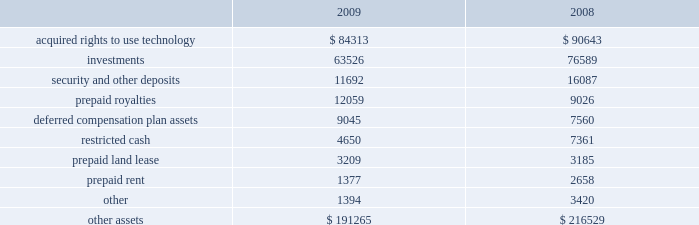Adobe systems incorporated notes to consolidated financial statements ( continued ) note 8 .
Other assets other assets as of november 27 , 2009 and november 28 , 2008 consisted of the following ( in thousands ) : .
Acquired rights to use technology purchased during fiscal 2009 and fiscal 2008 was $ 6.0 million and $ 100.4 million , respectively .
Of the cost for fiscal 2008 , an estimated $ 56.4 million was related to future licensing rights and has been capitalized and is being amortized on a straight-line basis over the estimated useful lives up to fifteen years .
Of the remaining costs for fiscal 2008 , we estimated that $ 27.2 million was related to historical use of licensing rights which was expensed as cost of sales and the residual of $ 16.8 million for fiscal 2008 was expensed as general and administrative costs .
In connection with these licensing arrangements , we have the ability to acquire additional rights to use technology in the future .
See note 17 for further information regarding our contractual commitments .
In general , acquired rights to use technology are amortized over their estimated useful lives of 3 to 15 years .
Included in investments are our indirect investments through our limited partnership interest in adobe ventures of approximately $ 37.1 million and $ 39.0 million as of november 27 , 2009 and november 28 , 2008 , respectively , which is consolidated in accordance with the provisions for consolidating variable interest entities .
The partnership is controlled by granite ventures , an independent venture capital firm and sole general partner of adobe ventures .
We are the primary beneficiary of adobe ventures and bear virtually all of the risks and rewards related to our ownership .
Our investment in adobe ventures does not have a significant impact on our consolidated financial position , results of operations or cash flows .
Adobe ventures carries its investments in equity securities at estimated fair value and investment gains and losses are included in our consolidated statements of income .
Substantially all of the investments held by adobe ventures at november 27 , 2009 and november 28 , 2008 are not publicly traded and , therefore , there is no established market for these securities .
In order to determine the fair value of these investments , we use the most recent round of financing involving new non-strategic investors or estimates of current market value made by granite ventures .
It is our policy to evaluate the fair value of these investments held by adobe ventures , as well as our direct investments , on a regular basis .
This evaluation includes , but is not limited to , reviewing each company 2019s cash position , financing needs , earnings and revenue outlook , operational performance , management and ownership changes and competition .
In the case of privately-held companies , this evaluation is based on information that we request from these companies .
This information is not subject to the same disclosure regulations as u.s .
Publicly traded companies and as such , the basis for these evaluations is subject to the timing and the accuracy of the data received from these companies .
See note 4 for further information regarding adobe ventures .
Also included in investments are our direct investments in privately-held companies of approximately $ 26.4 million and $ 37.6 million as of november 27 , 2009 and november 28 , 2008 , respectively , which are accounted for based on the cost method .
We assess these investments for impairment in value as circumstances dictate .
See note 4 for further information regarding our cost method investments .
We entered into a purchase and sale agreement , effective may 12 , 2008 , for the acquisition of real property located in waltham , massachusetts .
We purchased the property upon completion of construction of an office building shell and core , parking structure , and site improvements .
The purchase price for the property was $ 44.7 million and closed on june 16 , 2009 .
We made an initial deposit of $ 7.0 million which was included in security and other deposits as of november 28 , 2008 and the remaining balance was paid at closing .
This deposit was held in escrow until closing and then applied to the purchase price. .
What portion of the prepaid rent is used during 2009? 
Computations: (1377 - 2658)
Answer: -1281.0. 